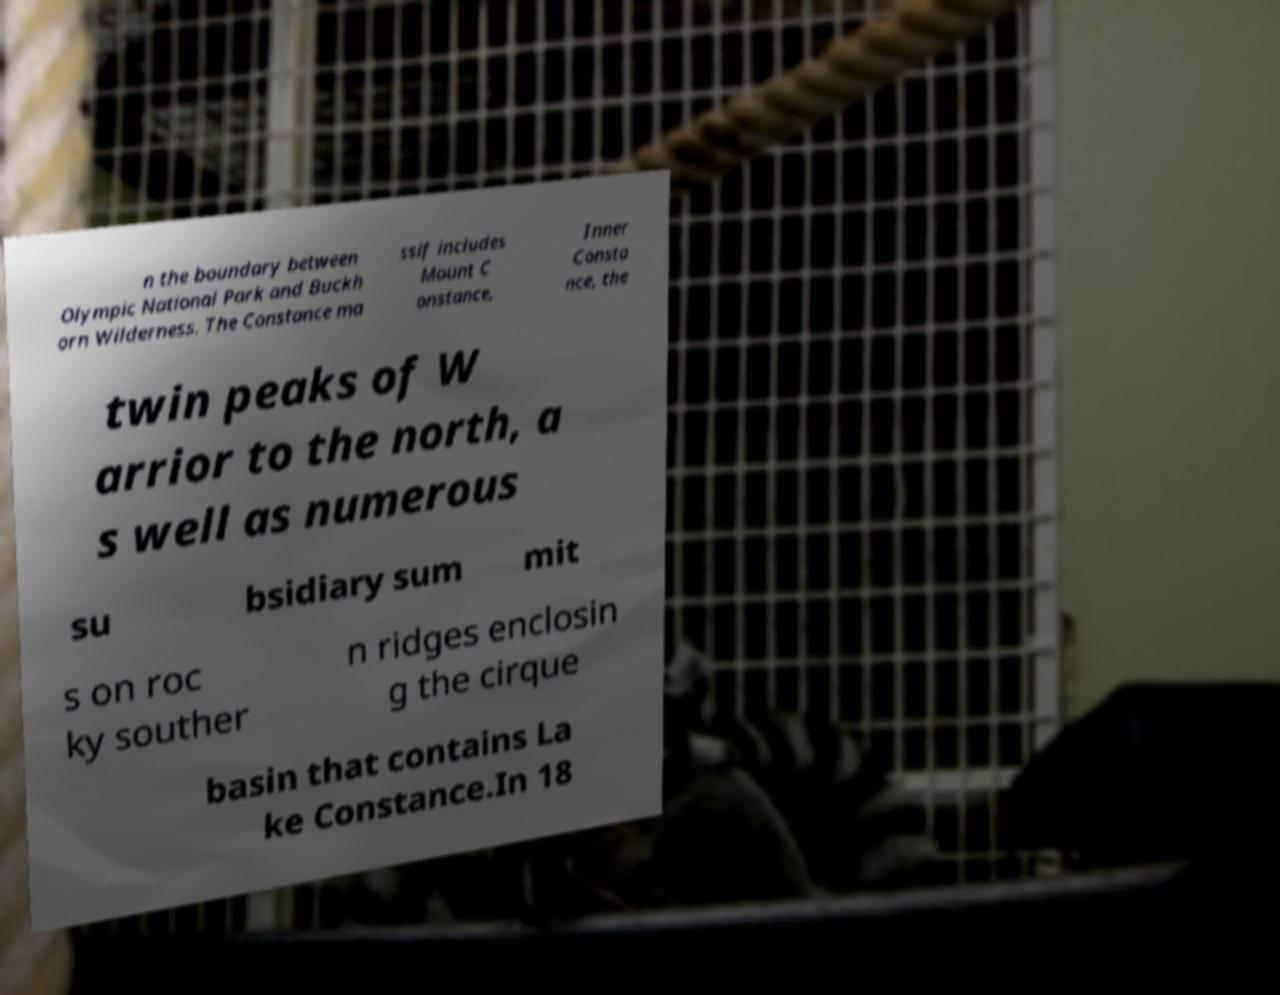Could you extract and type out the text from this image? n the boundary between Olympic National Park and Buckh orn Wilderness. The Constance ma ssif includes Mount C onstance, Inner Consta nce, the twin peaks of W arrior to the north, a s well as numerous su bsidiary sum mit s on roc ky souther n ridges enclosin g the cirque basin that contains La ke Constance.In 18 